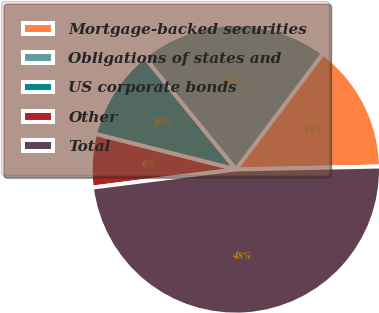<chart> <loc_0><loc_0><loc_500><loc_500><pie_chart><fcel>Mortgage-backed securities<fcel>Obligations of states and<fcel>US corporate bonds<fcel>Other<fcel>Total<nl><fcel>14.42%<fcel>21.14%<fcel>10.18%<fcel>5.94%<fcel>48.33%<nl></chart> 